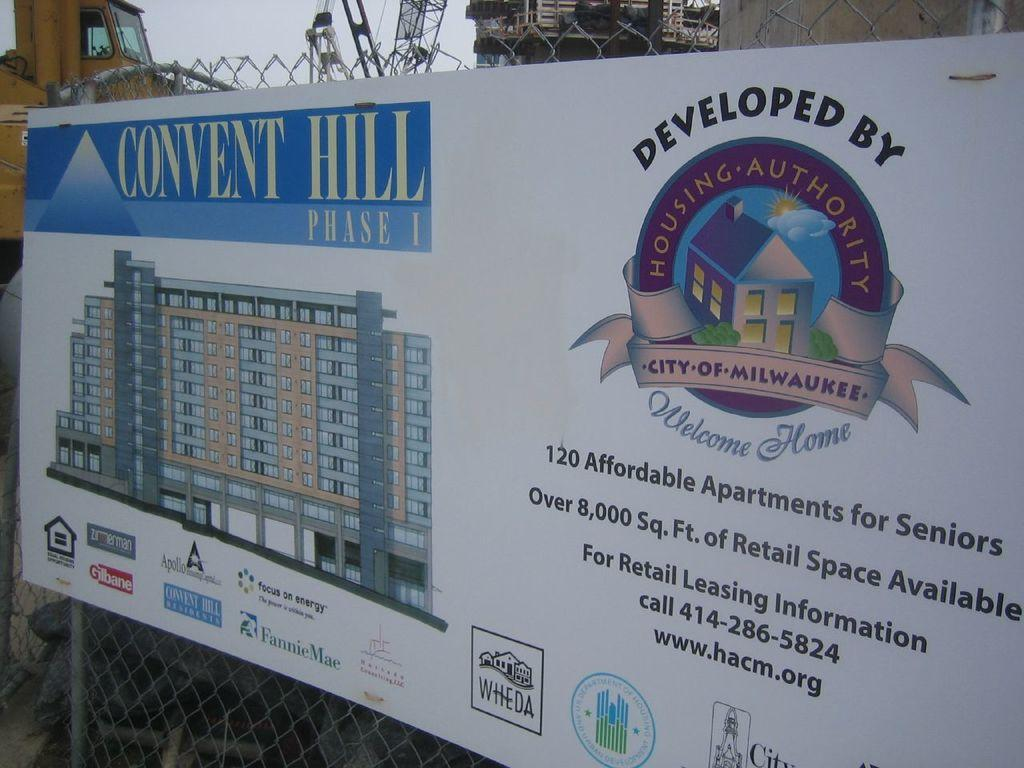What is the main object in the image? There is a board in the image. What type of material is present in the image? There is a mesh in the image. What can be seen at the top of the image? Vehicles, towers, a wall, and the sky are visible at the top of the image. Where is the ground visible in the image? The ground is visible in the bottom left corner of the image. What is the opinion of the cloud in the image? There is no cloud present in the image, so it is not possible to determine its opinion. 